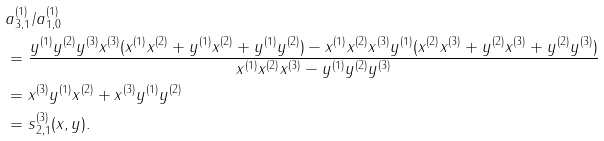<formula> <loc_0><loc_0><loc_500><loc_500>& a ^ { ( 1 ) } _ { 3 , 1 } / a ^ { ( 1 ) } _ { 1 , 0 } \\ & = \frac { y ^ { ( 1 ) } y ^ { ( 2 ) } y ^ { ( 3 ) } x ^ { ( 3 ) } ( x ^ { ( 1 ) } x ^ { ( 2 ) } + y ^ { ( 1 ) } x ^ { ( 2 ) } + y ^ { ( 1 ) } y ^ { ( 2 ) } ) - x ^ { ( 1 ) } x ^ { ( 2 ) } x ^ { ( 3 ) } y ^ { ( 1 ) } ( x ^ { ( 2 ) } x ^ { ( 3 ) } + y ^ { ( 2 ) } x ^ { ( 3 ) } + y ^ { ( 2 ) } y ^ { ( 3 ) } ) } { x ^ { ( 1 ) } x ^ { ( 2 ) } x ^ { ( 3 ) } - y ^ { ( 1 ) } y ^ { ( 2 ) } y ^ { ( 3 ) } } \\ & = x ^ { ( 3 ) } y ^ { ( 1 ) } x ^ { ( 2 ) } + x ^ { ( 3 ) } y ^ { ( 1 ) } y ^ { ( 2 ) } \\ & = s ^ { ( 3 ) } _ { 2 , 1 } ( x , y ) .</formula> 